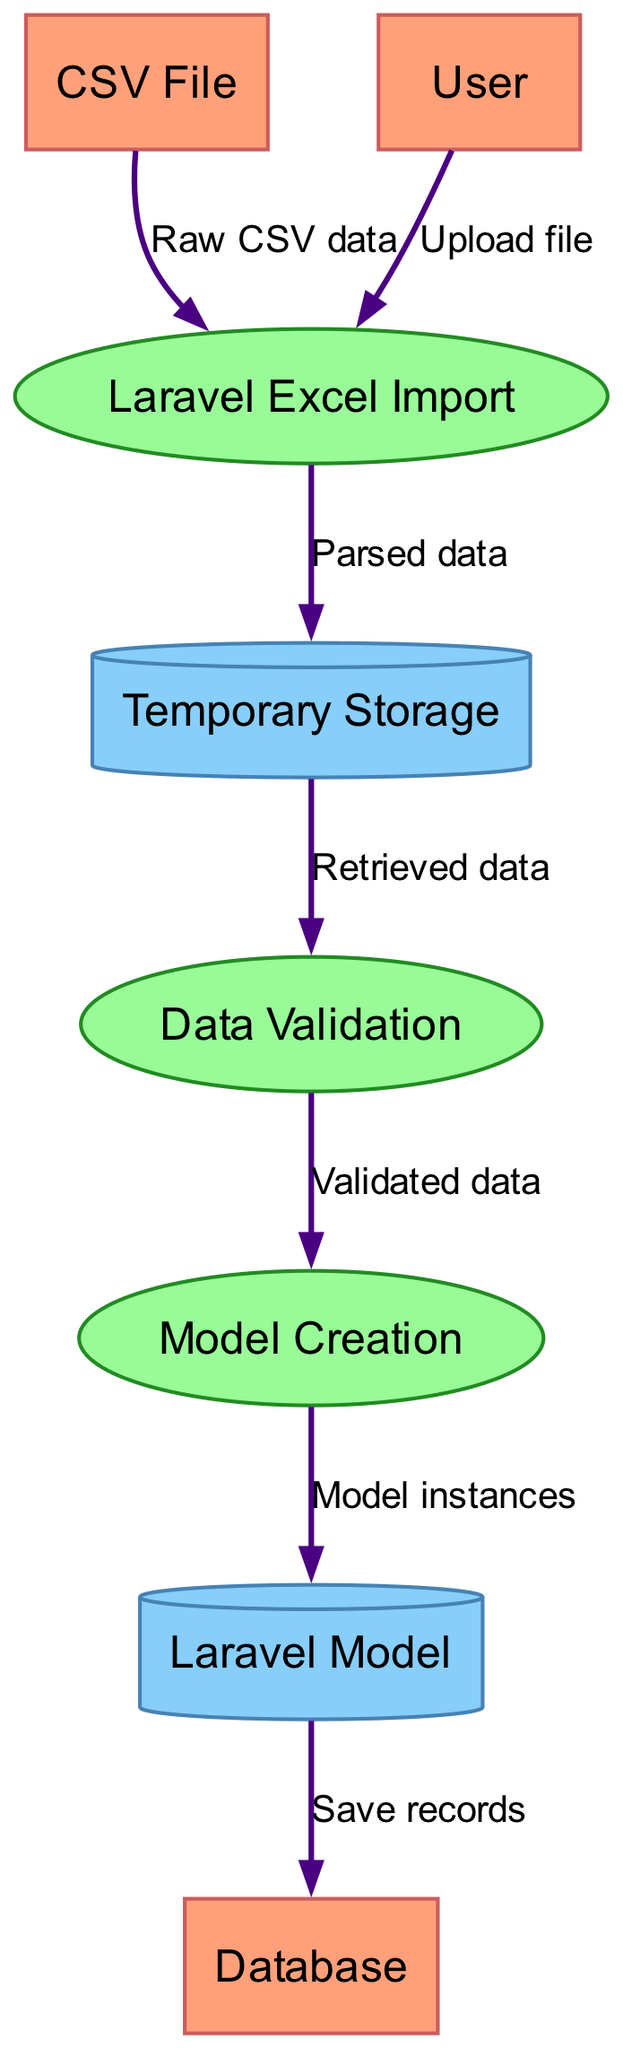What are the external entities in the diagram? The diagram lists three external entities: "CSV File", "User", and "Database". These are the sources or destinations of data within the process.
Answer: CSV File, User, Database How many processes are involved in the data flow? The diagram indicates that there are three processes: "Laravel Excel Import", "Data Validation", and "Model Creation". Therefore, the total number of processes is three.
Answer: 3 Which process outputs to the "Temporary Storage"? The "Laravel Excel Import" process outputs "Parsed data" to the "Temporary Storage". This indicates that this process is responsible for parsing the raw CSV data before it is stored temporarily.
Answer: Laravel Excel Import What type of storage is "Temporary Storage"? In the diagram, "Temporary Storage" is classified as a data store, specifically depicted as a cylinder. This indicates it serves to hold data temporarily during the process.
Answer: Data store What is the final destination after "Model Creation"? Following "Model Creation", the output labeled "Model instances" flows to the "Laravel Model". Thus, the final destination of the output from the "Model Creation" process is the "Laravel Model".
Answer: Laravel Model How many data flows are there in total? The diagram illustrates six distinct data flows occurring between various entities, processes, and stores. Thus, the total count of data flows present is six.
Answer: 6 Which process comes before "Data Validation"? The "Temporary Storage" is the source of input data to the "Data Validation" process. Thus, it can be concluded that "Temporary Storage" is the process that comes immediately before "Data Validation".
Answer: Temporary Storage What type of entity is "Database"? The "Database" in this diagram is classified as an external entity, which suggests that it interacts with the system but does not undergo any internal processing.
Answer: External entity Which type of storage is used to store "Model instances"? The "Model instances" are stored in the "Laravel Model", which is defined as a data store in the diagram specifically for holding the model data.
Answer: Data store 